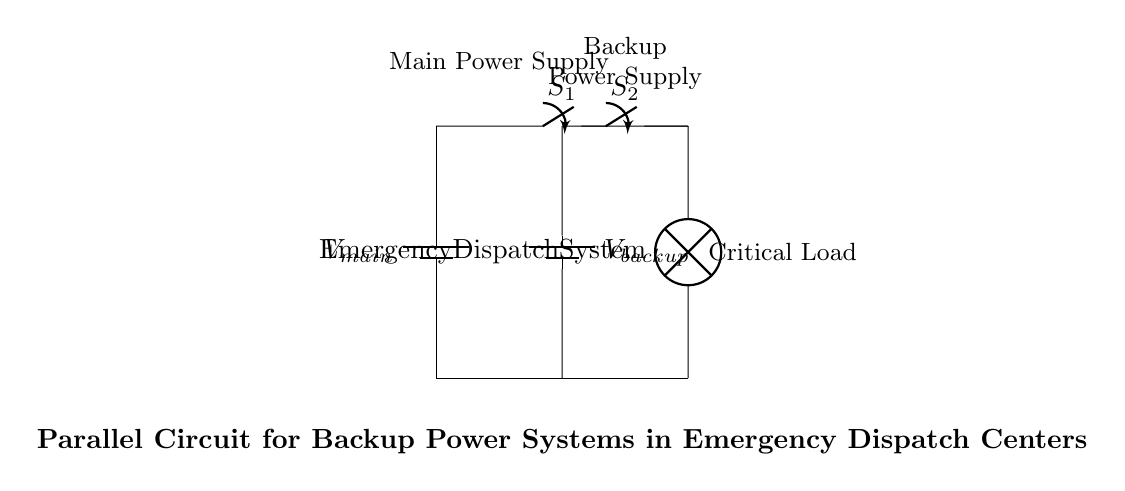What are the two power sources in the circuit? The circuit contains two power sources: the main power supply and the backup power supply, which are represented by two batteries in parallel.
Answer: main power supply and backup power supply What is the function of the switches labeled S1 and S2? The switches S1 and S2 control the connection of the main and backup power supplies to the load, allowing for seamless switching between power sources depending on availability.
Answer: control power sources How many batteries are in the circuit? The circuit has two batteries, one for the main power and one for the backup.
Answer: two If the main power fails, what happens to the backup power supply? If the main power fails, the backup power supply (the second battery) continues to provide power to the load, ensuring that the emergency dispatch system remains operational.
Answer: provides power What type of circuit configuration is used for the backup power system? The backup power system uses a parallel circuit configuration, allowing multiple power sources to supply the load simultaneously or independently.
Answer: parallel What is the load in this circuit? The load in this circuit is the emergency dispatch system, represented by the lamp component in the diagram.
Answer: Emergency Dispatch System If both power supplies were connected to the load, how would the voltage across the load behave? In a parallel circuit, the voltage across the load remains constant and is equal to the voltage of the supply with the higher voltage, as both supplies are connected directly across the load.
Answer: remains constant 